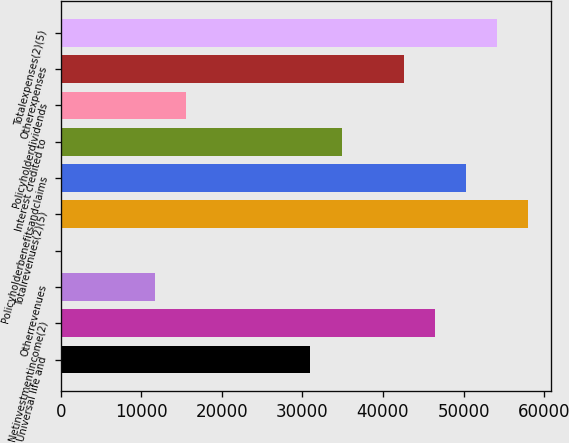<chart> <loc_0><loc_0><loc_500><loc_500><bar_chart><fcel>Universal life and<fcel>Netinvestmentincome(2)<fcel>Otherrevenues<fcel>Unnamed: 3<fcel>Totalrevenues(2)(5)<fcel>Policyholderbenefitsandclaims<fcel>Interest credited to<fcel>Policyholderdividends<fcel>Otherexpenses<fcel>Totalexpenses(2)(5)<nl><fcel>31004.6<fcel>46419.4<fcel>11736.1<fcel>175<fcel>57980.5<fcel>50273.1<fcel>34858.3<fcel>15589.8<fcel>42565.7<fcel>54126.8<nl></chart> 